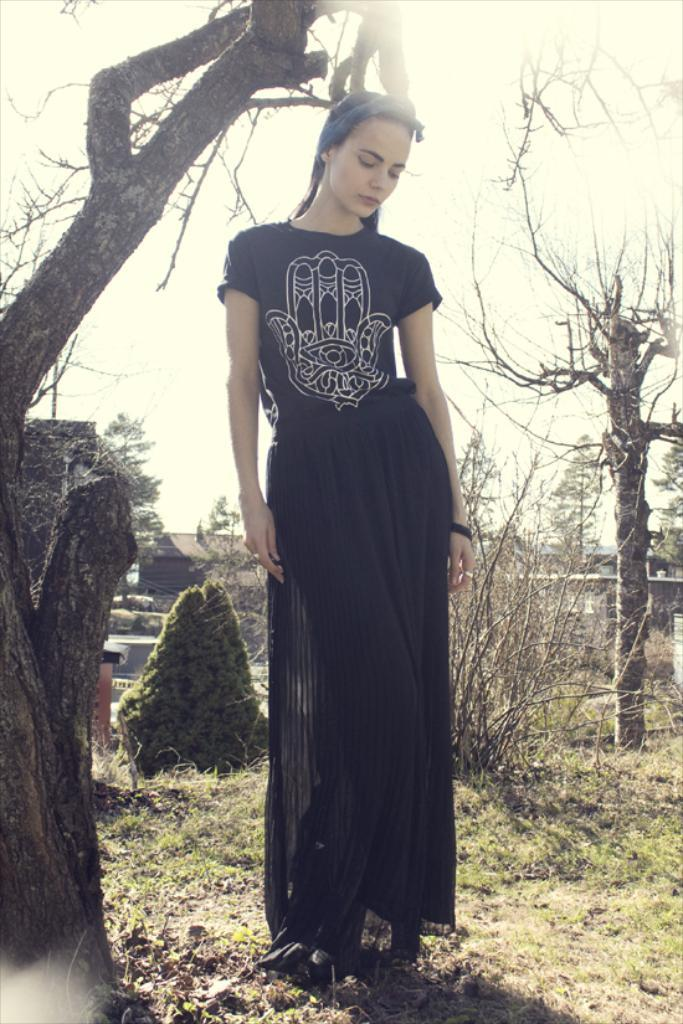What is the main subject of the image? There is a woman standing in the center of the image. What can be seen in the background of the image? There are houses, trees, and plants in the background of the image. What type of vegetation is at the bottom of the image? There is grass at the bottom of the image. What type of card is being used by the woman in the image? There is no card present in the image; the woman is simply standing in the center. 